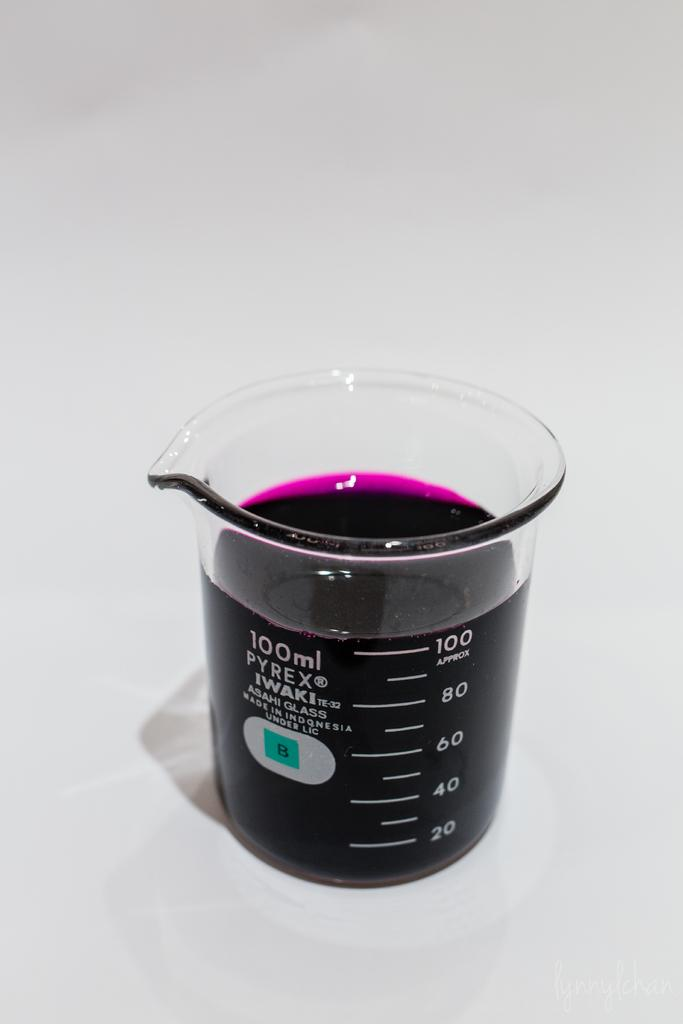What object is present in the image that is used for measuring? There is a measuring jar in the image. What is inside the measuring jar? The measuring jar contains liquid. On what surface is the measuring jar placed? The measuring jar is placed on a white surface. What type of voice can be heard coming from the measuring jar in the image? There is no voice present in the image, as it features a measuring jar containing liquid on a white surface. 